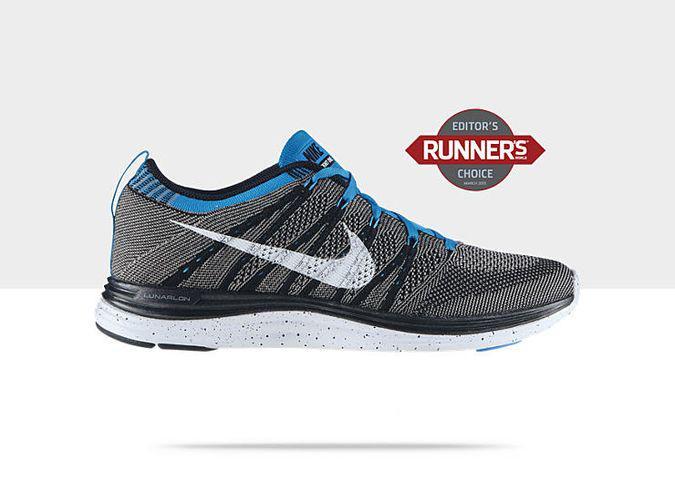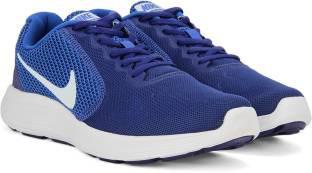The first image is the image on the left, the second image is the image on the right. Assess this claim about the two images: "One image shows a matching pair of shoe facing the right.". Correct or not? Answer yes or no. Yes. The first image is the image on the left, the second image is the image on the right. For the images shown, is this caption "The shoes are flat on the ground and sitting right next to each other in the right image." true? Answer yes or no. Yes. 